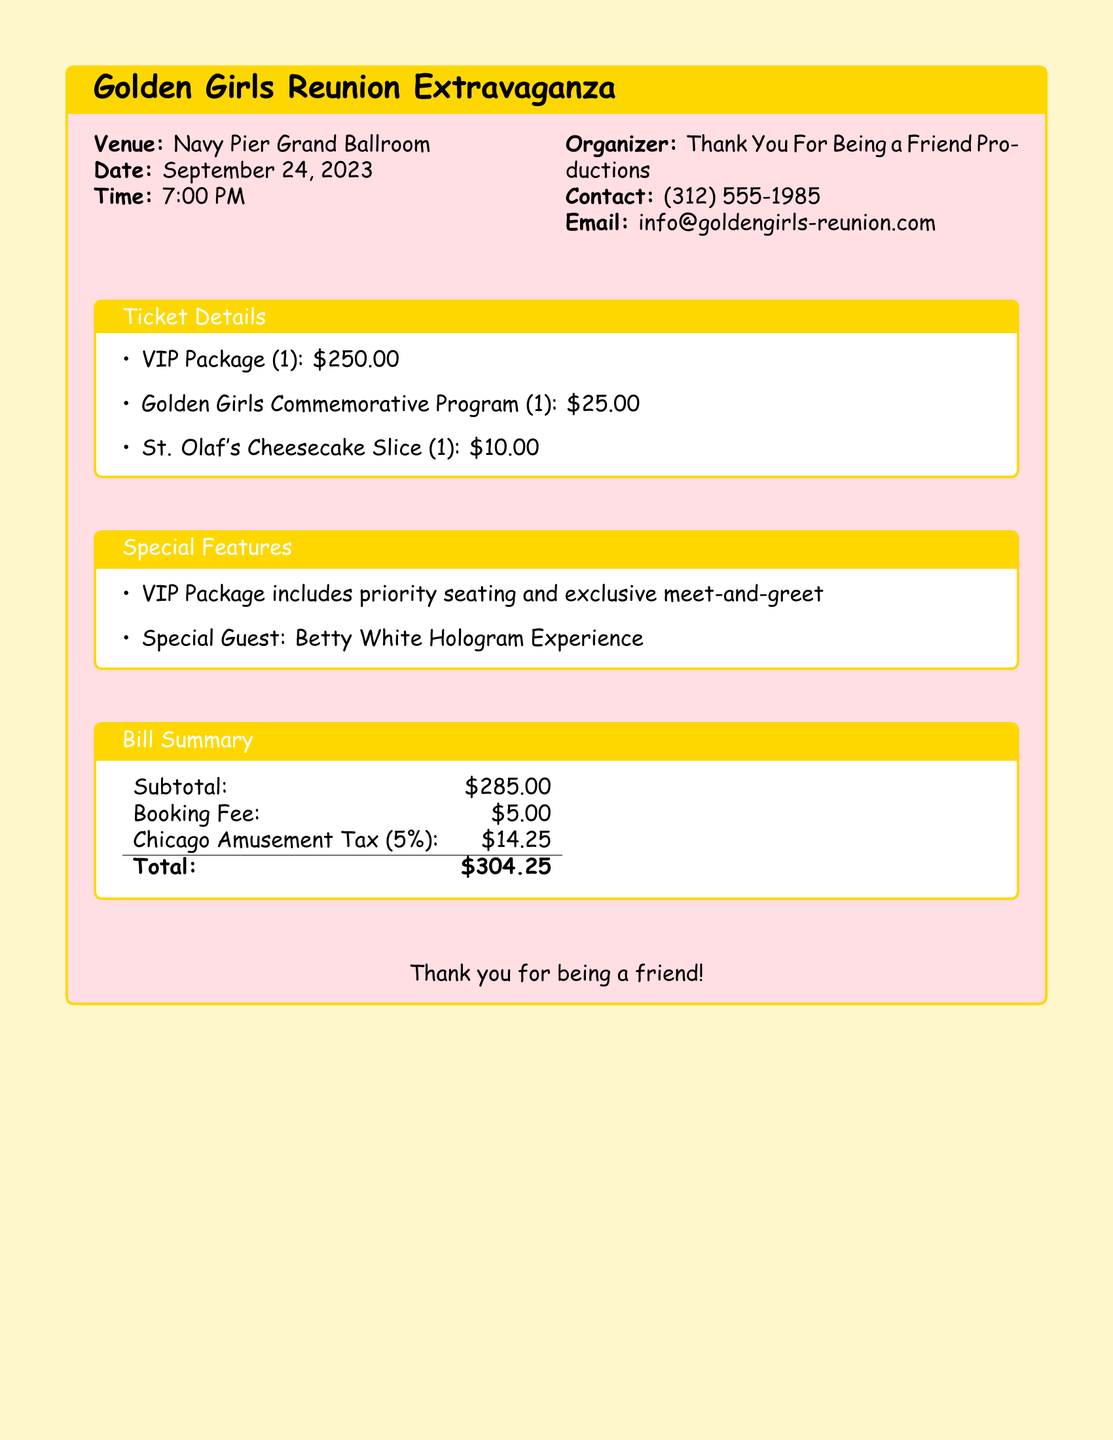what is the venue for the event? The venue is specified in the document as the Navy Pier Grand Ballroom.
Answer: Navy Pier Grand Ballroom what is the date of the Golden Girls reunion event? The date is listed in the document as September 24, 2023.
Answer: September 24, 2023 how much does the VIP package cost? The price for the VIP package is stated as $250.00.
Answer: $250.00 what is included in the VIP package? The document mentions that the VIP package includes priority seating and exclusive meet-and-greet.
Answer: priority seating and exclusive meet-and-greet what is the total amount due on the bill? The total due is shown in the document as $304.25.
Answer: $304.25 what is the Chicago amusement tax percentage? The document states that the Chicago amusement tax is 5%.
Answer: 5% who organized the event? The organizer is identified in the document as Thank You For Being a Friend Productions.
Answer: Thank You For Being a Friend Productions what item costs $10.00? The document lists St. Olaf's Cheesecake Slice as costing $10.00.
Answer: St. Olaf's Cheesecake Slice what special guest is mentioned for the reunion? The document features the Betty White Hologram Experience as the special guest.
Answer: Betty White Hologram Experience 